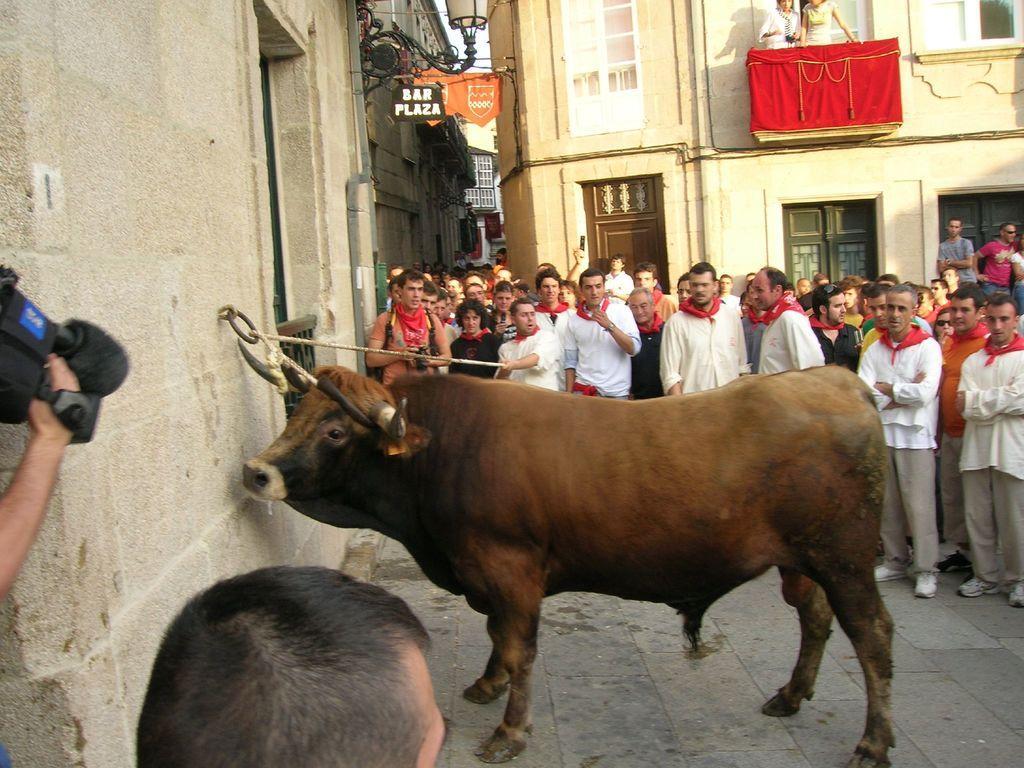Describe this image in one or two sentences. In this image there is bull tied to a wall and a rope is caught by a person, around the bull there are crowd, behind the crowd there are buildings. 